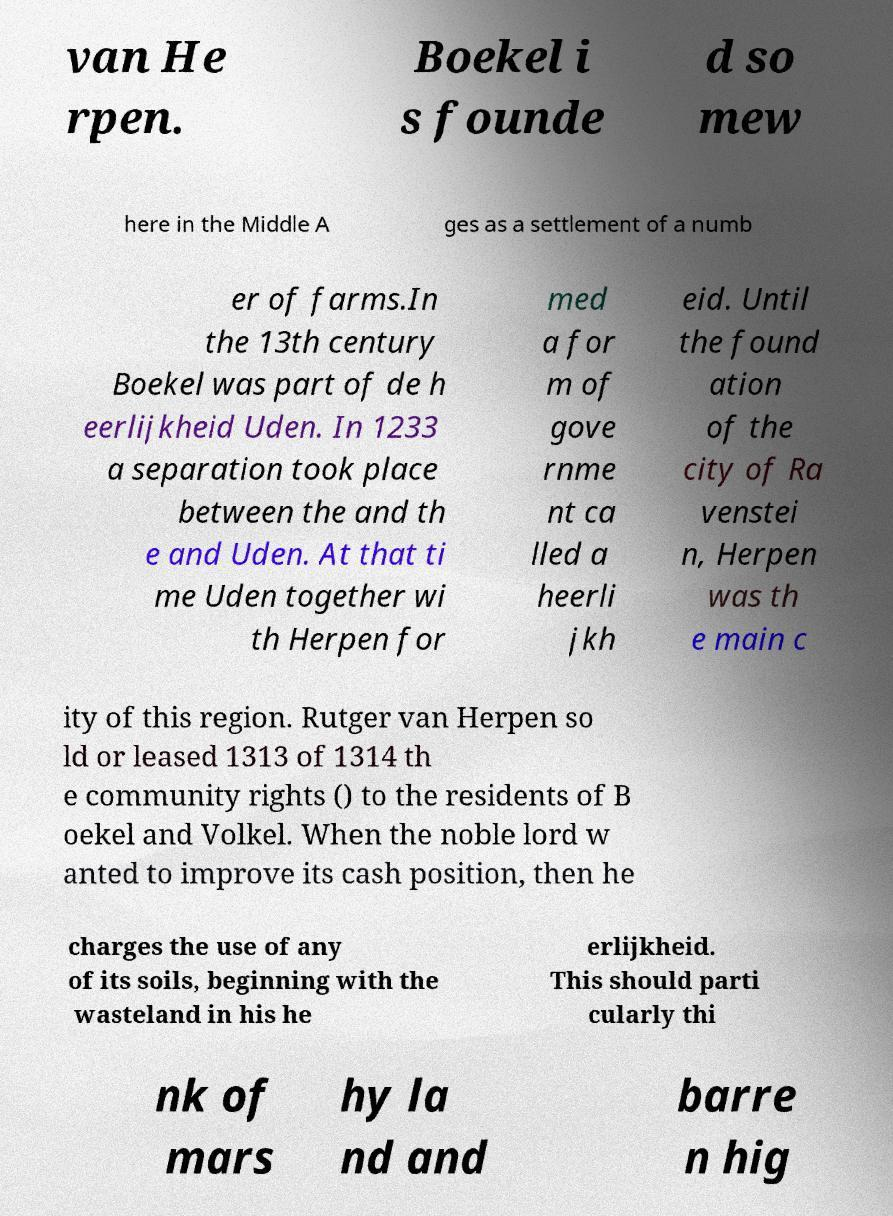I need the written content from this picture converted into text. Can you do that? van He rpen. Boekel i s founde d so mew here in the Middle A ges as a settlement of a numb er of farms.In the 13th century Boekel was part of de h eerlijkheid Uden. In 1233 a separation took place between the and th e and Uden. At that ti me Uden together wi th Herpen for med a for m of gove rnme nt ca lled a heerli jkh eid. Until the found ation of the city of Ra venstei n, Herpen was th e main c ity of this region. Rutger van Herpen so ld or leased 1313 of 1314 th e community rights () to the residents of B oekel and Volkel. When the noble lord w anted to improve its cash position, then he charges the use of any of its soils, beginning with the wasteland in his he erlijkheid. This should parti cularly thi nk of mars hy la nd and barre n hig 